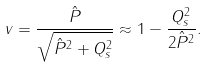Convert formula to latex. <formula><loc_0><loc_0><loc_500><loc_500>v = { \frac { \hat { P } } { \sqrt { \hat { P } ^ { 2 } + Q _ { s } ^ { 2 } } } } \approx 1 - { \frac { Q _ { s } ^ { 2 } } { 2 \hat { P } ^ { 2 } } } .</formula> 